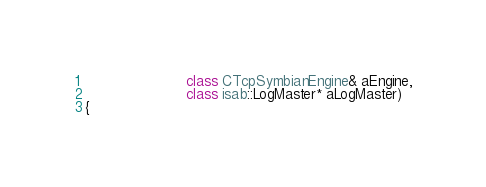<code> <loc_0><loc_0><loc_500><loc_500><_C++_>                       class CTcpSymbianEngine& aEngine,
                       class isab::LogMaster* aLogMaster)
{</code> 